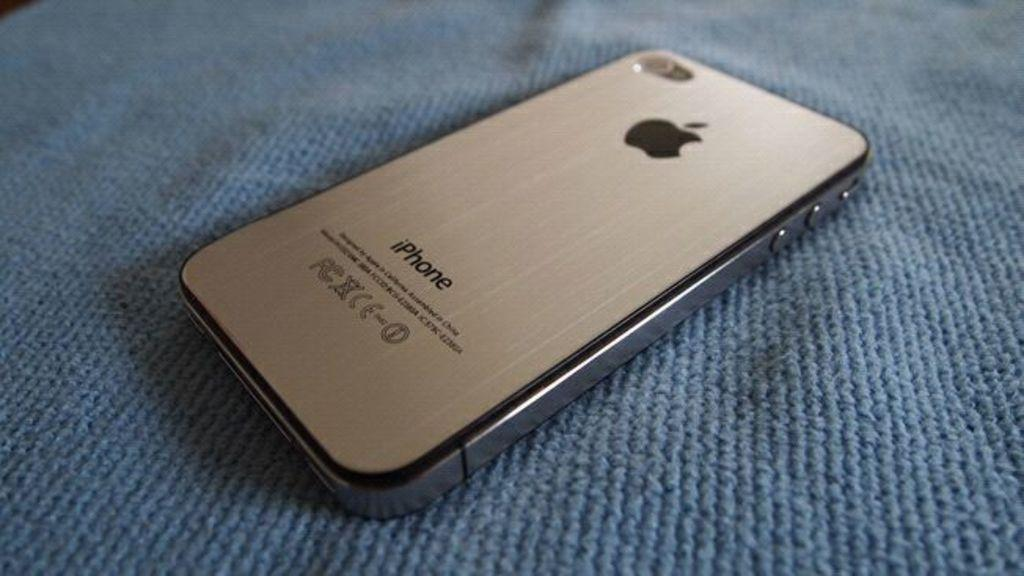<image>
Summarize the visual content of the image. A silver Apple phone says iPhone on the back and is facing down on a blanket. 